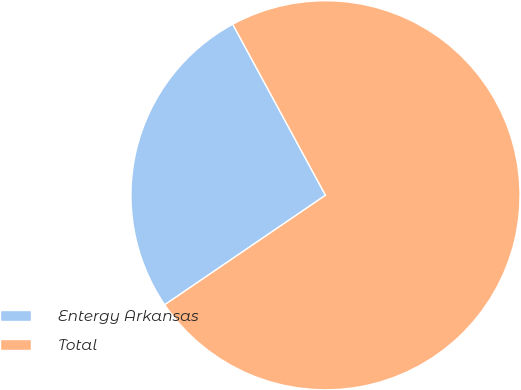Convert chart to OTSL. <chart><loc_0><loc_0><loc_500><loc_500><pie_chart><fcel>Entergy Arkansas<fcel>Total<nl><fcel>26.61%<fcel>73.39%<nl></chart> 